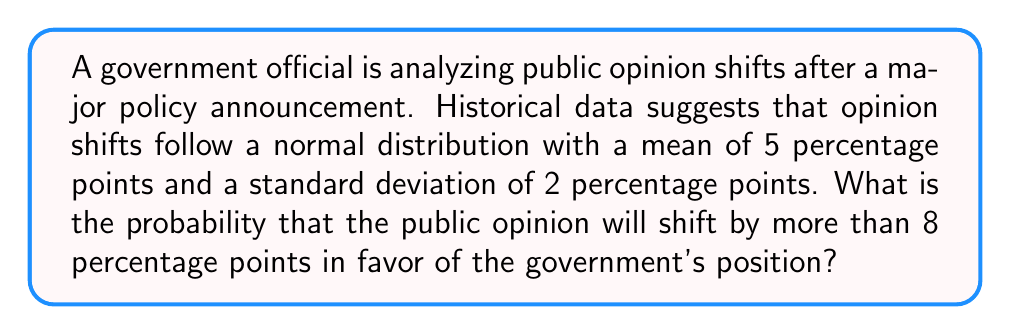Solve this math problem. Let's approach this step-by-step:

1) We are given that the opinion shifts follow a normal distribution with:
   $\mu = 5$ (mean)
   $\sigma = 2$ (standard deviation)

2) We want to find $P(X > 8)$, where $X$ is the opinion shift.

3) To solve this, we need to standardize the normal distribution:
   $Z = \frac{X - \mu}{\sigma}$

4) We can rewrite our probability as:
   $P(X > 8) = P(Z > \frac{8 - 5}{2})$

5) Simplifying:
   $P(Z > \frac{3}{2}) = P(Z > 1.5)$

6) Using the standard normal distribution table or a calculator, we can find:
   $P(Z > 1.5) = 1 - P(Z < 1.5) = 1 - 0.9332 = 0.0668$

7) Therefore, the probability of an opinion shift greater than 8 percentage points is approximately 0.0668 or 6.68%.
Answer: 0.0668 